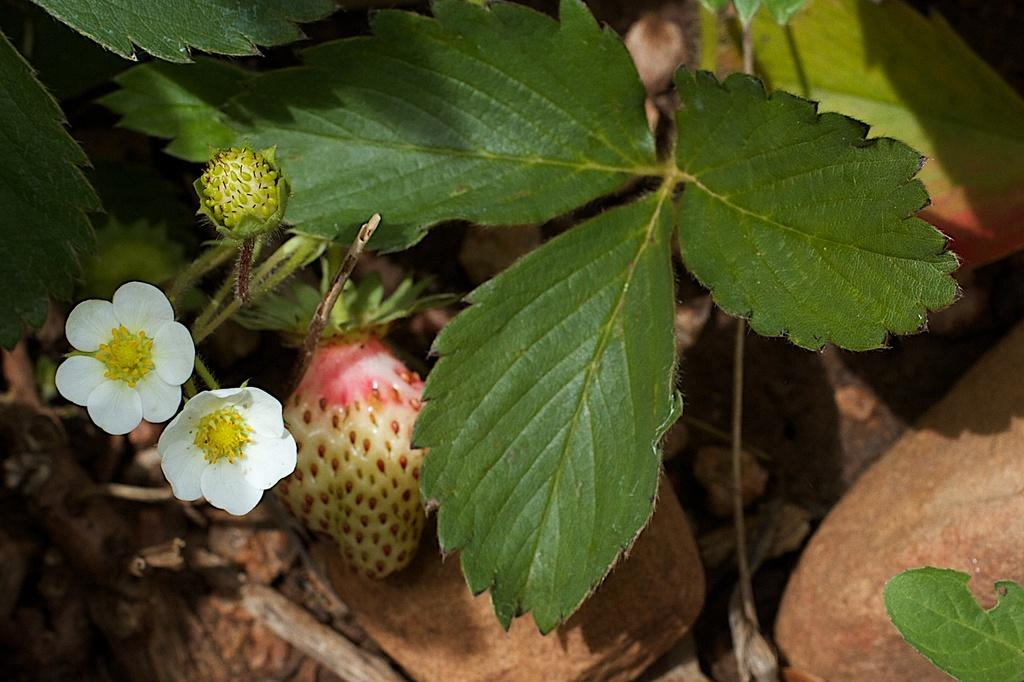What is located in the foreground of the image? There is a plant in the foreground of the image. How many flowers are on the plant? The plant has two flowers. What other features can be seen on the plant? The plant has a bud and a strawberry. What is present at the bottom of the plant? There are dried leaves at the bottom of the plant. What type of quilt is being used to cover the plant in the image? There is no quilt present in the image; it features a plant with flowers, a bud, a strawberry, and dried leaves. 